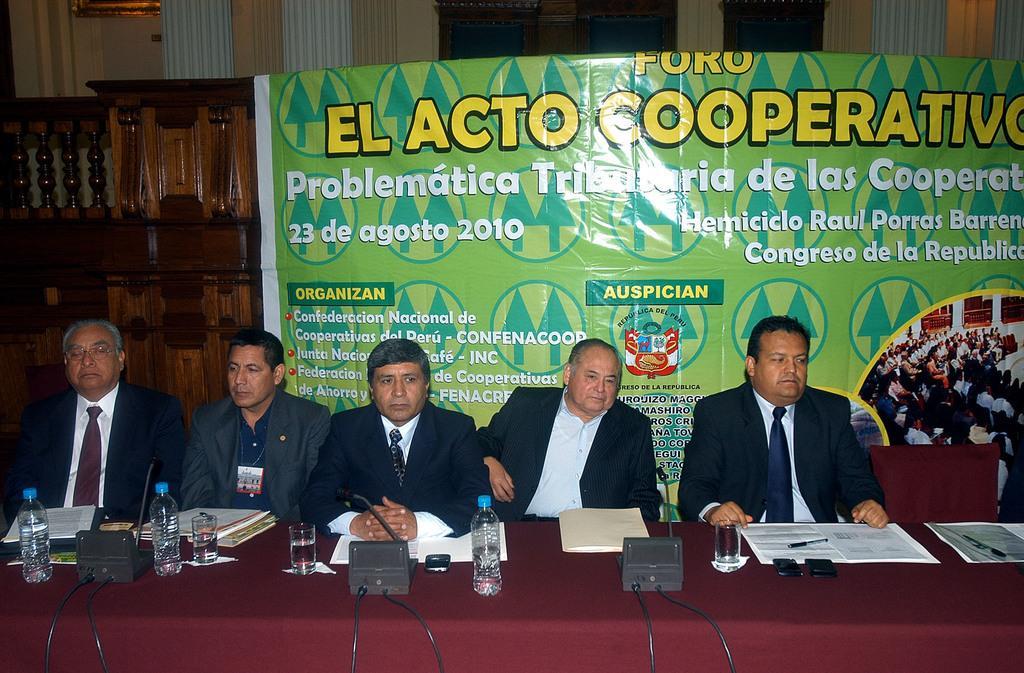In one or two sentences, can you explain what this image depicts? This picture describes about group of people, they are all seated on the chairs, in front of them we can see microphones, bottles, glasses, files and other things on the table, in the background we can see a hoarding. 